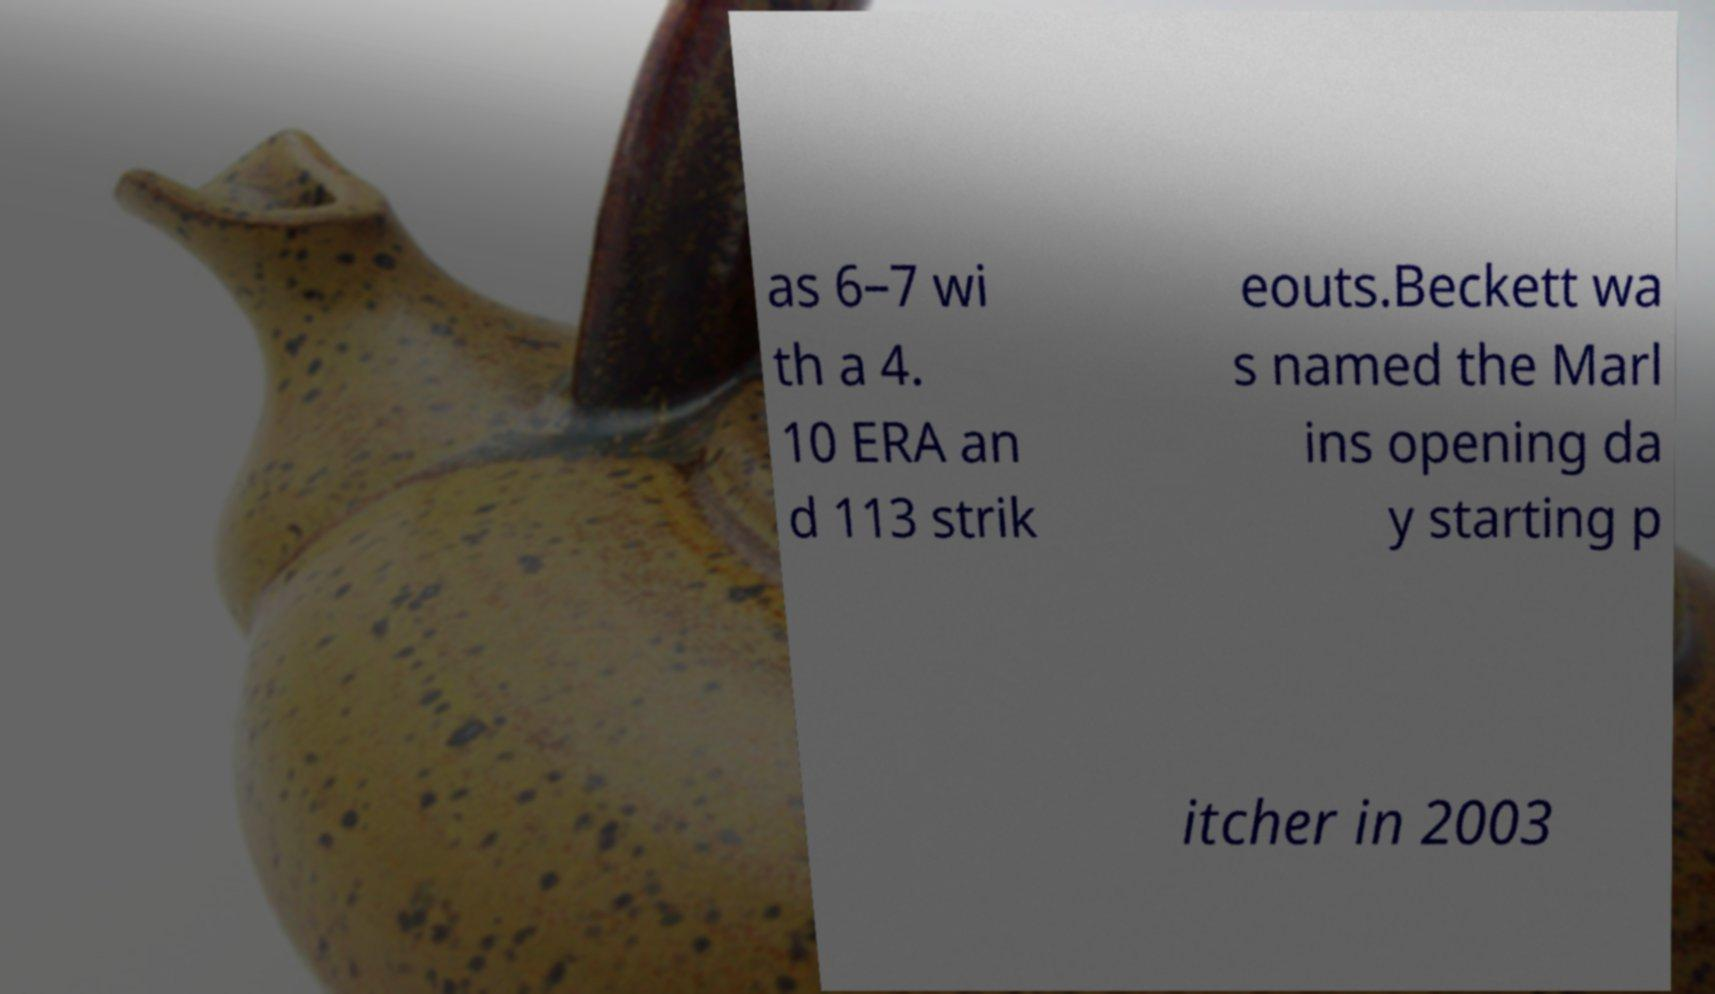Could you assist in decoding the text presented in this image and type it out clearly? as 6–7 wi th a 4. 10 ERA an d 113 strik eouts.Beckett wa s named the Marl ins opening da y starting p itcher in 2003 